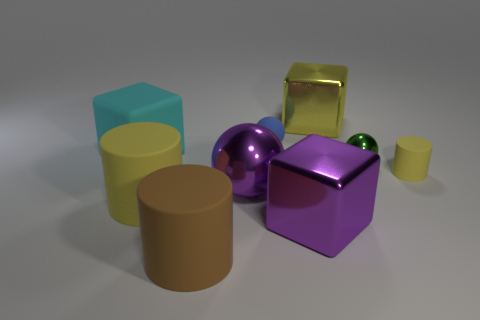Subtract all green metal spheres. How many spheres are left? 2 Subtract all blue cubes. How many yellow cylinders are left? 2 Subtract all cylinders. How many objects are left? 6 Subtract all small rubber things. Subtract all purple balls. How many objects are left? 6 Add 7 yellow objects. How many yellow objects are left? 10 Add 9 tiny purple shiny balls. How many tiny purple shiny balls exist? 9 Subtract 0 brown spheres. How many objects are left? 9 Subtract all yellow cylinders. Subtract all purple spheres. How many cylinders are left? 1 